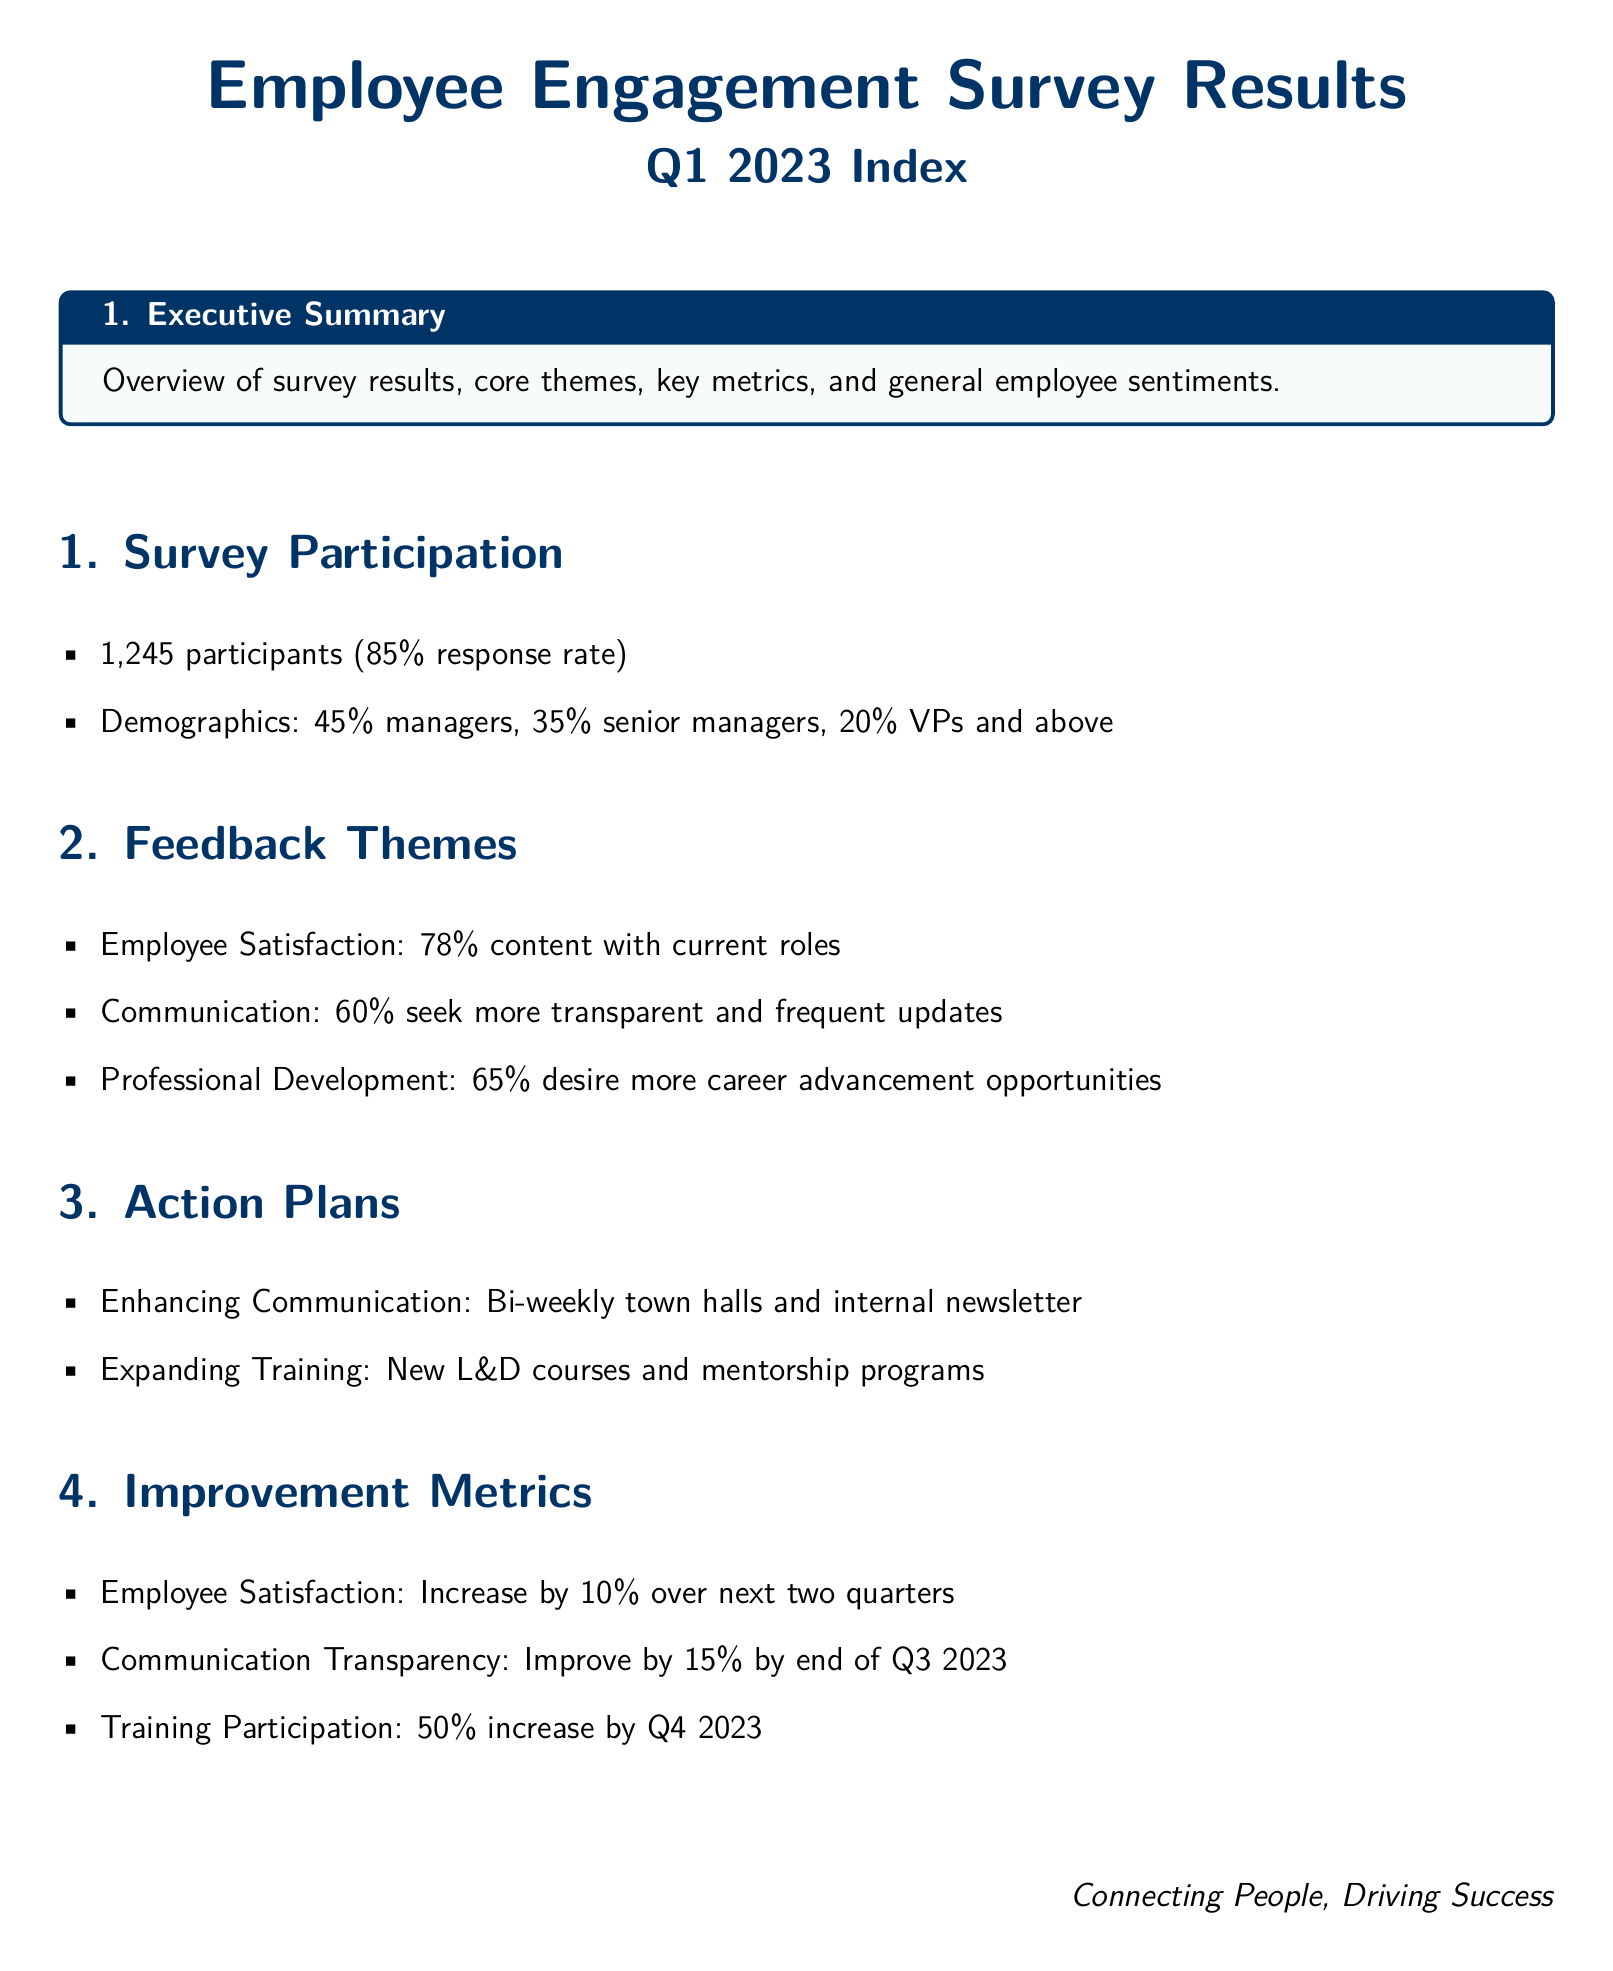What is the response rate of the survey? The response rate is calculated as the percentage of participants who completed the survey out of the total number approached. According to the document, the response rate is 85%.
Answer: 85% How many participants were involved in the survey? The total number of participants is explicitly mentioned in the document as part of the survey participation section. It states there were 1,245 participants.
Answer: 1,245 What percentage of employees is satisfied with their current roles? The document provides a specific percentage regarding employee satisfaction as one of the feedback themes. It states that 78% are content with their current roles.
Answer: 78% What is the desired percentage increase in employee satisfaction over the next two quarters? This is outlined in the improvement metrics section, which indicates a target percentage increase in employee satisfaction over the specified timeframe. The target is a 10% increase.
Answer: 10% What communication method is proposed to enhance transparency? The document details planned initiatives under the action plans to improve communication, specifically mentioning bi-weekly town halls as a method.
Answer: Bi-weekly town halls What is the target percentage improvement for communication transparency by the end of Q3 2023? The document sets a specific target improvement percentage for communication transparency in the improvement metrics section. The goal is to improve by 15%.
Answer: 15% What new initiative is planned to expand training opportunities? The action plans outline specific initiatives to improve training, and it mentions new learning and development (L&D) courses as one such initiative.
Answer: New L&D courses What is the focus of the document's overall theme? The document emphasizes the importance of connection and driving success, very much aligned with enhancing employee engagement.
Answer: Connecting people, driving success 